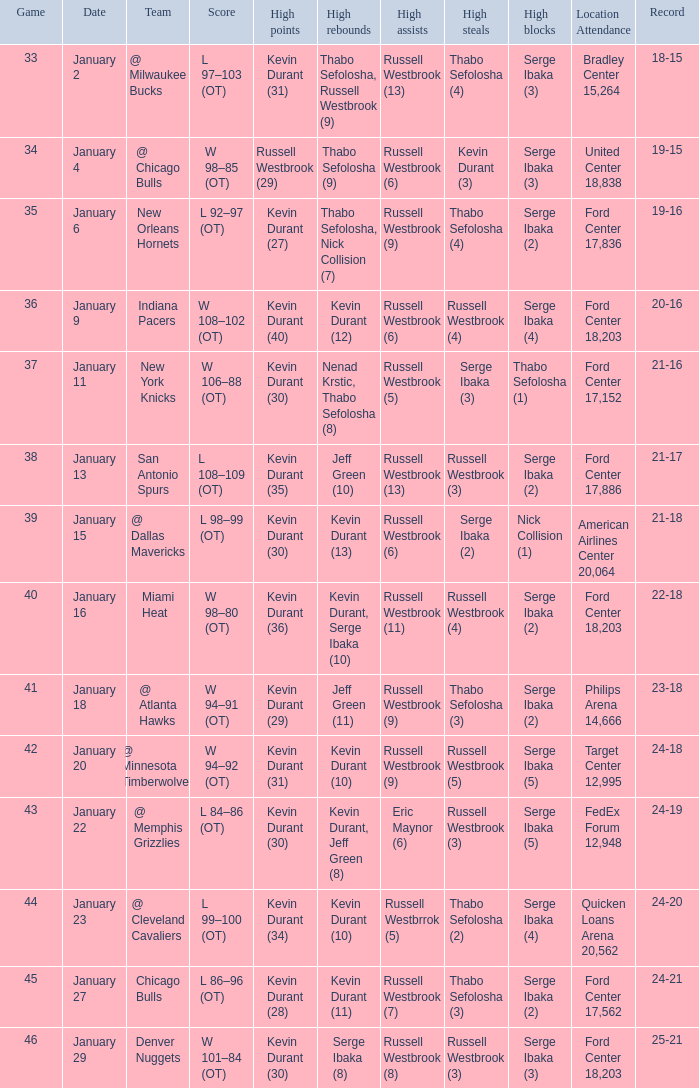Name the location attendance for january 18 Philips Arena 14,666. 